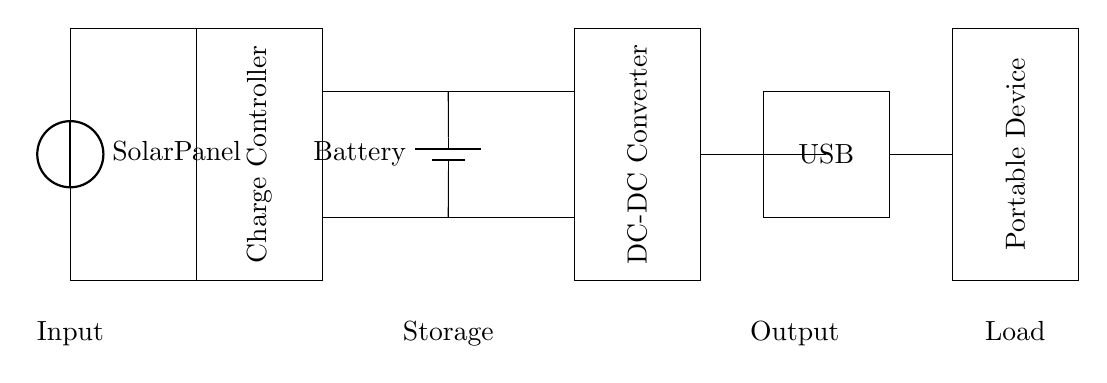What is the primary input source for this circuit? The primary input source is the solar panel, which converts sunlight into electrical energy. This can be identified at the beginning of the circuit diagram where the solar panel is depicted.
Answer: Solar panel What does the charge controller do in this circuit? The charge controller manages the charging of the battery, ensuring that it is charged at the correct voltage and current levels to prevent overcharging or damage. This is evident as it is placed directly after the solar panel and connects to the battery.
Answer: Manages charging What is the expected output voltage from the USB? The expected output voltage from the USB is typically 5 volts, which is a standard for USB-powered devices. The diagram implies connectivity from the DC-DC converter to the USB.
Answer: 5 volts What component converts DC voltage to other levels in this circuit? The DC-DC converter is the component responsible for converting DC voltage from the battery to either a higher or lower level suitable for the USB output. It is clearly marked and connected to both the battery and USB output lines.
Answer: DC-DC converter Why is a battery included in the circuit? A battery is included to store energy generated by the solar panel during daytime for use when direct sunlight isn't available, providing a stable power supply for the portable device. The presence of a battery in the circuit illustrates its role in energy storage.
Answer: To store energy How does the circuit ensure that the portable device receives power when needed? The circuit includes a combination of solar power collection, battery storage, and a DC-DC converter, which together enable the system to provide consistent power to the portable device whenever it is required, regardless of solar conditions. The connectivity shown indicates this flow of energy.
Answer: Through solar, battery, and converter 